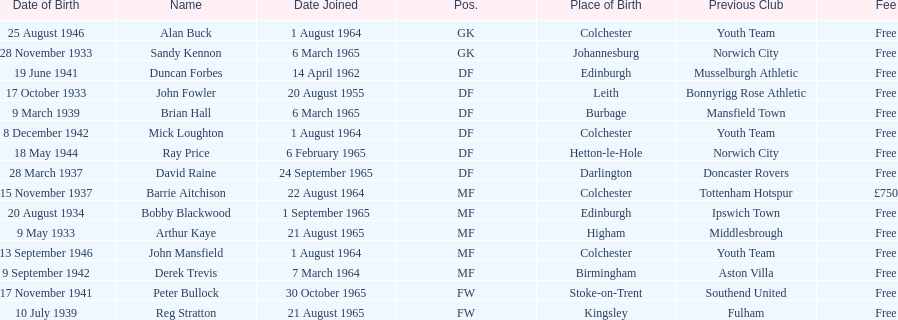What is the alternate cost specified, aside from free? £750. Could you parse the entire table as a dict? {'header': ['Date of Birth', 'Name', 'Date Joined', 'Pos.', 'Place of Birth', 'Previous Club', 'Fee'], 'rows': [['25 August 1946', 'Alan Buck', '1 August 1964', 'GK', 'Colchester', 'Youth Team', 'Free'], ['28 November 1933', 'Sandy Kennon', '6 March 1965', 'GK', 'Johannesburg', 'Norwich City', 'Free'], ['19 June 1941', 'Duncan Forbes', '14 April 1962', 'DF', 'Edinburgh', 'Musselburgh Athletic', 'Free'], ['17 October 1933', 'John Fowler', '20 August 1955', 'DF', 'Leith', 'Bonnyrigg Rose Athletic', 'Free'], ['9 March 1939', 'Brian Hall', '6 March 1965', 'DF', 'Burbage', 'Mansfield Town', 'Free'], ['8 December 1942', 'Mick Loughton', '1 August 1964', 'DF', 'Colchester', 'Youth Team', 'Free'], ['18 May 1944', 'Ray Price', '6 February 1965', 'DF', 'Hetton-le-Hole', 'Norwich City', 'Free'], ['28 March 1937', 'David Raine', '24 September 1965', 'DF', 'Darlington', 'Doncaster Rovers', 'Free'], ['15 November 1937', 'Barrie Aitchison', '22 August 1964', 'MF', 'Colchester', 'Tottenham Hotspur', '£750'], ['20 August 1934', 'Bobby Blackwood', '1 September 1965', 'MF', 'Edinburgh', 'Ipswich Town', 'Free'], ['9 May 1933', 'Arthur Kaye', '21 August 1965', 'MF', 'Higham', 'Middlesbrough', 'Free'], ['13 September 1946', 'John Mansfield', '1 August 1964', 'MF', 'Colchester', 'Youth Team', 'Free'], ['9 September 1942', 'Derek Trevis', '7 March 1964', 'MF', 'Birmingham', 'Aston Villa', 'Free'], ['17 November 1941', 'Peter Bullock', '30 October 1965', 'FW', 'Stoke-on-Trent', 'Southend United', 'Free'], ['10 July 1939', 'Reg Stratton', '21 August 1965', 'FW', 'Kingsley', 'Fulham', 'Free']]} 